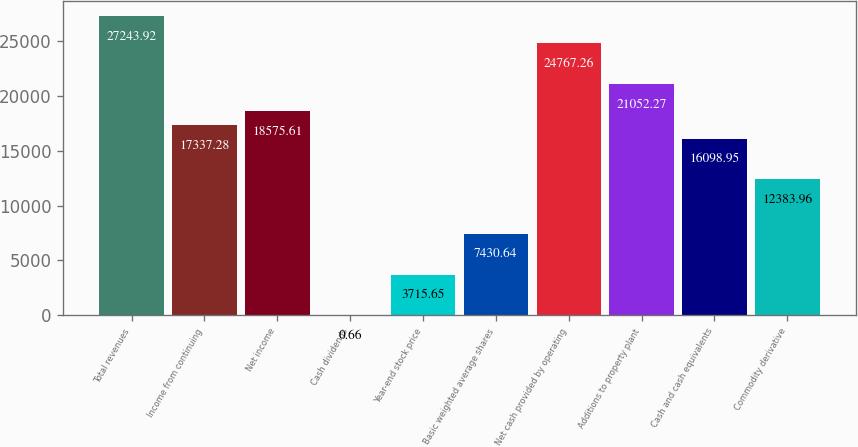Convert chart to OTSL. <chart><loc_0><loc_0><loc_500><loc_500><bar_chart><fcel>Total revenues<fcel>Income from continuing<fcel>Net income<fcel>Cash dividends<fcel>Year-end stock price<fcel>Basic weighted average shares<fcel>Net cash provided by operating<fcel>Additions to property plant<fcel>Cash and cash equivalents<fcel>Commodity derivative<nl><fcel>27243.9<fcel>17337.3<fcel>18575.6<fcel>0.66<fcel>3715.65<fcel>7430.64<fcel>24767.3<fcel>21052.3<fcel>16099<fcel>12384<nl></chart> 